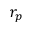Convert formula to latex. <formula><loc_0><loc_0><loc_500><loc_500>r _ { p }</formula> 